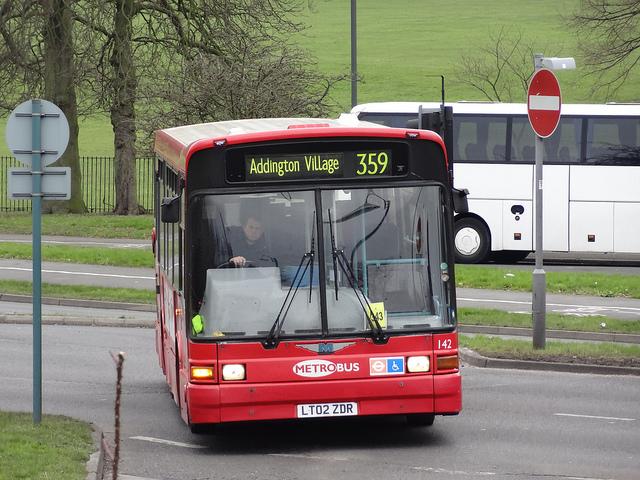What number is this bus?
Answer briefly. 359. Where is the bus going?
Give a very brief answer. Addington village. What does the round red sign signify?
Answer briefly. Do not enter. 